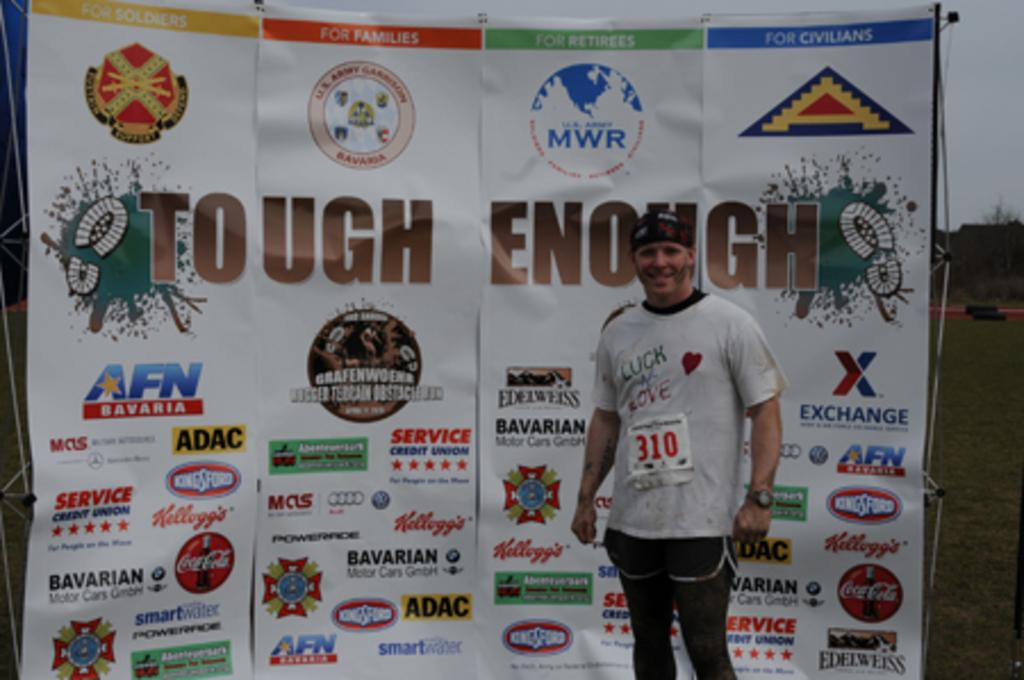<image>
Relay a brief, clear account of the picture shown. A man stands in front of a Tough Enough sign. 